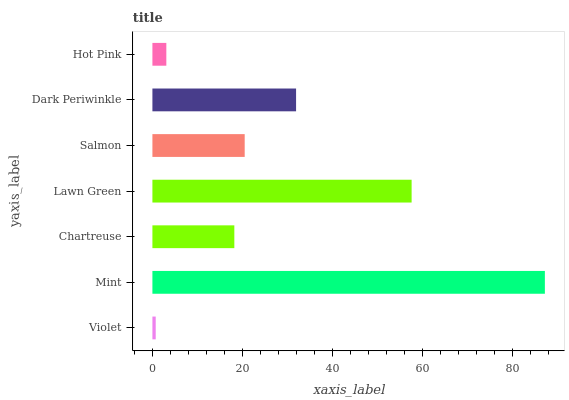Is Violet the minimum?
Answer yes or no. Yes. Is Mint the maximum?
Answer yes or no. Yes. Is Chartreuse the minimum?
Answer yes or no. No. Is Chartreuse the maximum?
Answer yes or no. No. Is Mint greater than Chartreuse?
Answer yes or no. Yes. Is Chartreuse less than Mint?
Answer yes or no. Yes. Is Chartreuse greater than Mint?
Answer yes or no. No. Is Mint less than Chartreuse?
Answer yes or no. No. Is Salmon the high median?
Answer yes or no. Yes. Is Salmon the low median?
Answer yes or no. Yes. Is Mint the high median?
Answer yes or no. No. Is Chartreuse the low median?
Answer yes or no. No. 